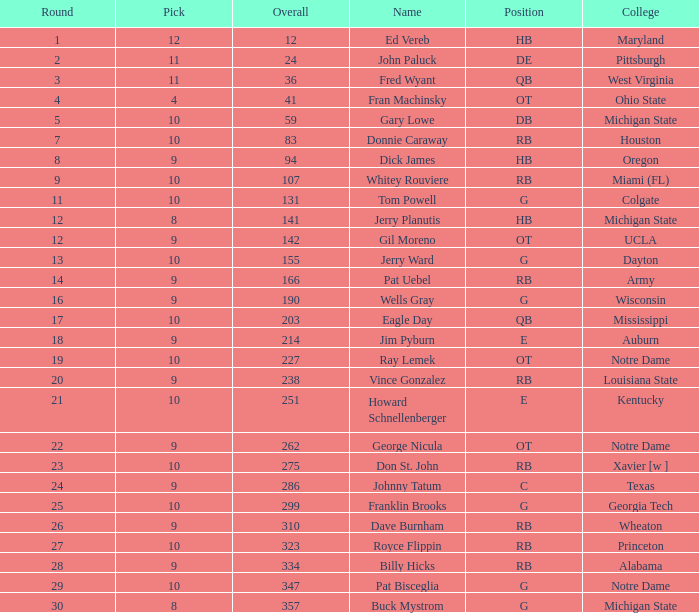What is the aggregate count of overall selections that occurred after pick 9 and were for auburn college? 0.0. 